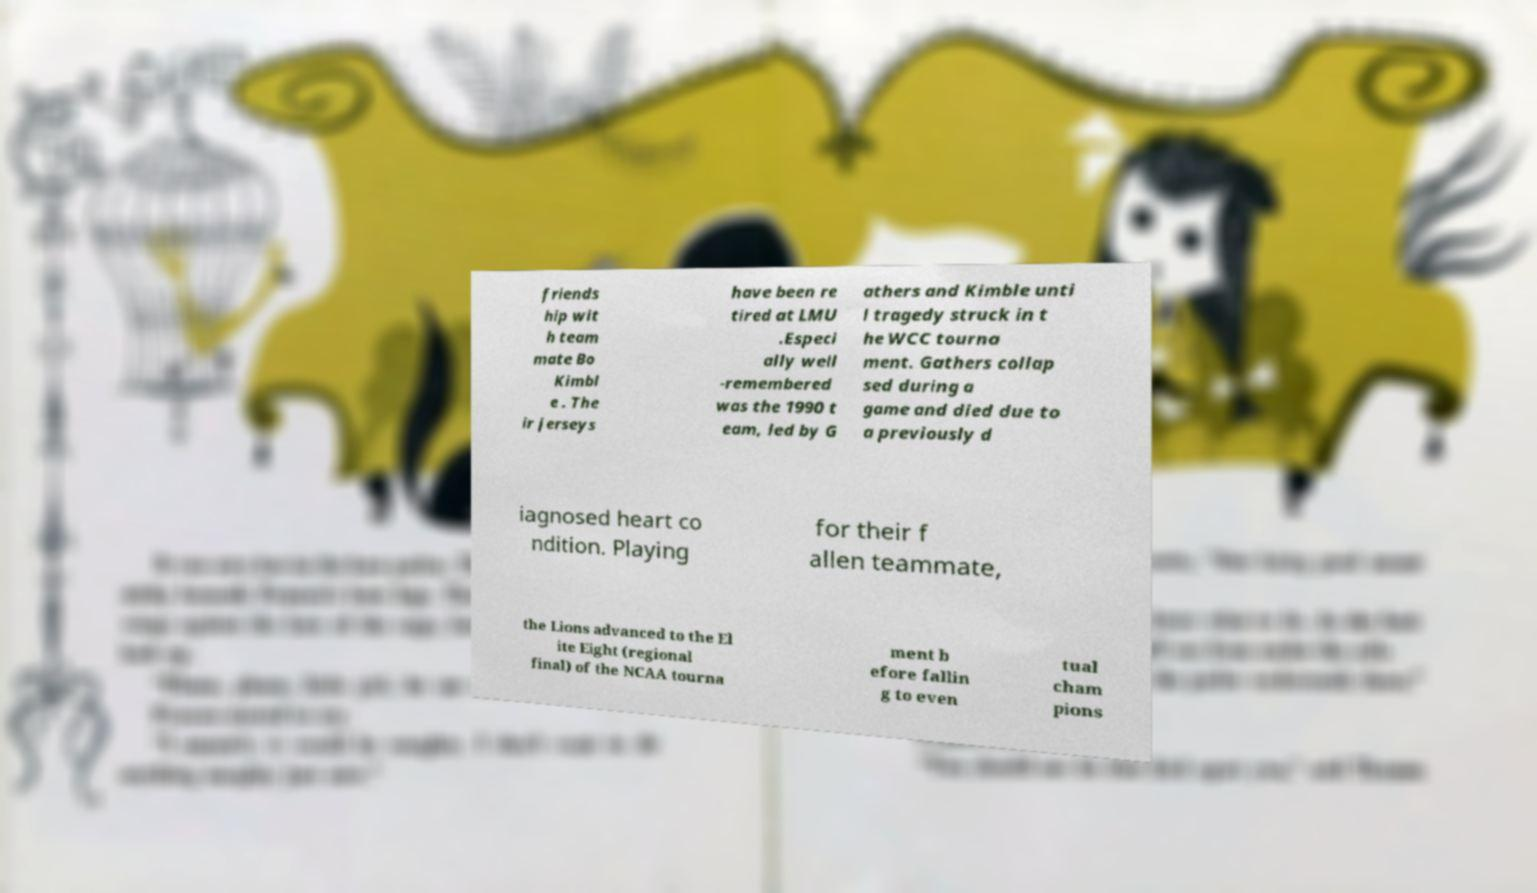There's text embedded in this image that I need extracted. Can you transcribe it verbatim? friends hip wit h team mate Bo Kimbl e . The ir jerseys have been re tired at LMU .Especi ally well -remembered was the 1990 t eam, led by G athers and Kimble unti l tragedy struck in t he WCC tourna ment. Gathers collap sed during a game and died due to a previously d iagnosed heart co ndition. Playing for their f allen teammate, the Lions advanced to the El ite Eight (regional final) of the NCAA tourna ment b efore fallin g to even tual cham pions 